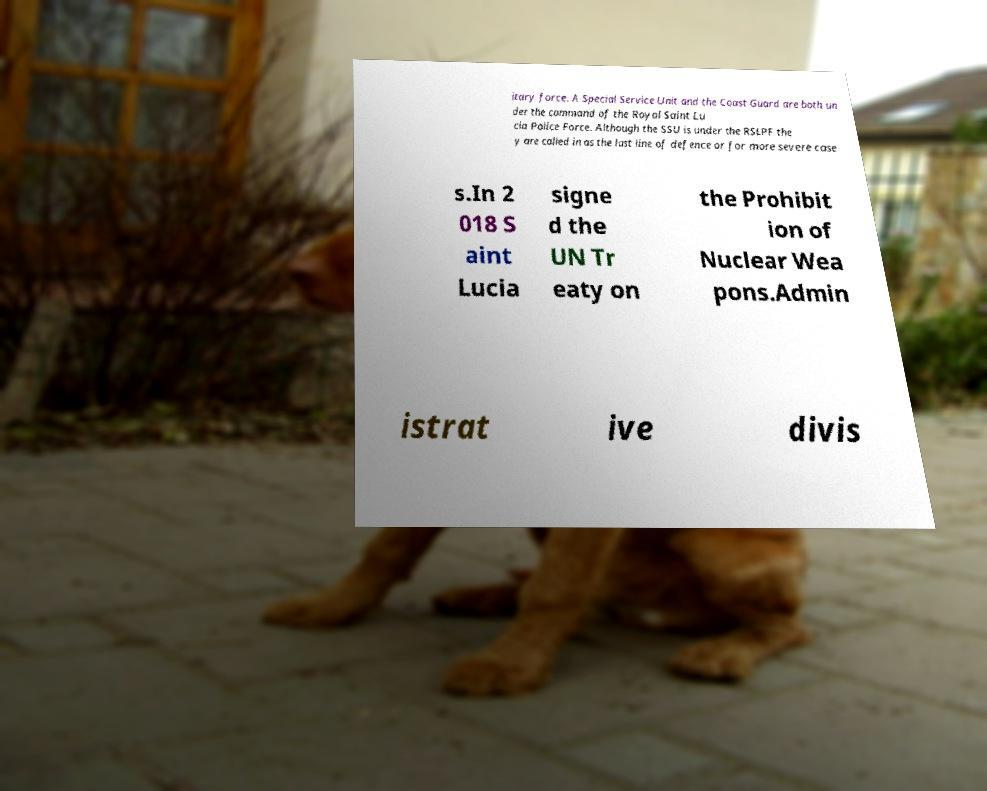Can you accurately transcribe the text from the provided image for me? itary force. A Special Service Unit and the Coast Guard are both un der the command of the Royal Saint Lu cia Police Force. Although the SSU is under the RSLPF the y are called in as the last line of defence or for more severe case s.In 2 018 S aint Lucia signe d the UN Tr eaty on the Prohibit ion of Nuclear Wea pons.Admin istrat ive divis 